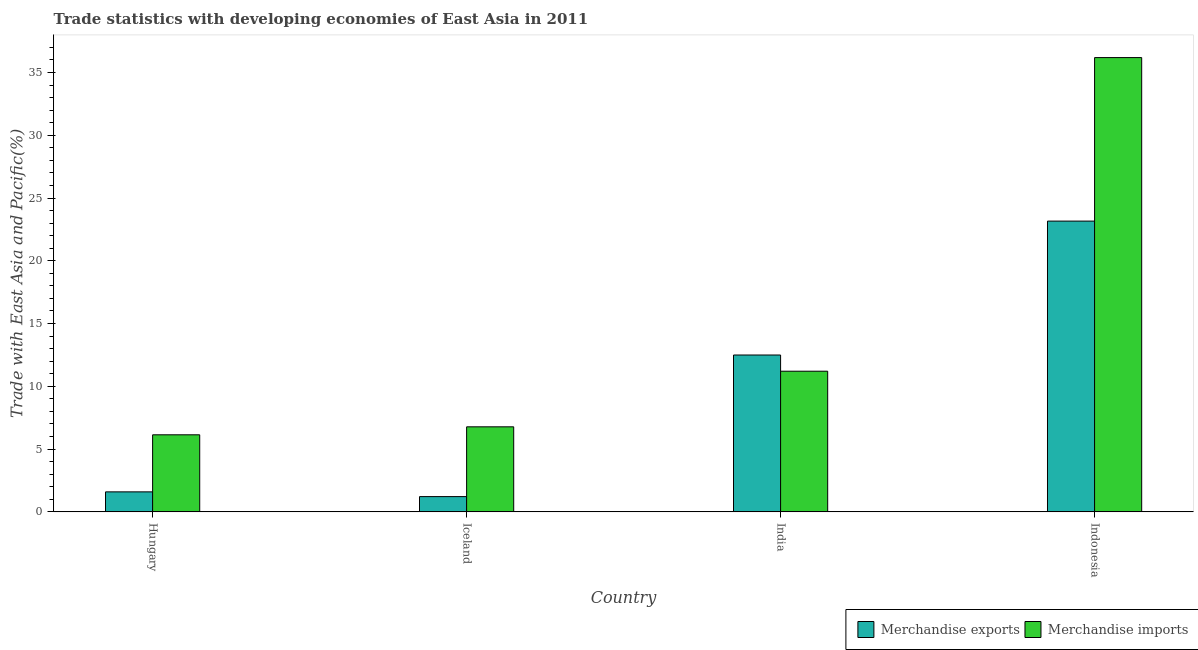How many groups of bars are there?
Make the answer very short. 4. Are the number of bars on each tick of the X-axis equal?
Offer a terse response. Yes. How many bars are there on the 3rd tick from the right?
Give a very brief answer. 2. What is the merchandise exports in Indonesia?
Ensure brevity in your answer.  23.16. Across all countries, what is the maximum merchandise imports?
Make the answer very short. 36.18. Across all countries, what is the minimum merchandise exports?
Give a very brief answer. 1.22. In which country was the merchandise imports minimum?
Ensure brevity in your answer.  Hungary. What is the total merchandise exports in the graph?
Your answer should be compact. 38.46. What is the difference between the merchandise exports in Hungary and that in India?
Make the answer very short. -10.9. What is the difference between the merchandise imports in Indonesia and the merchandise exports in Hungary?
Keep it short and to the point. 34.59. What is the average merchandise exports per country?
Ensure brevity in your answer.  9.62. What is the difference between the merchandise imports and merchandise exports in Indonesia?
Offer a terse response. 13.02. In how many countries, is the merchandise imports greater than 12 %?
Ensure brevity in your answer.  1. What is the ratio of the merchandise imports in Iceland to that in Indonesia?
Keep it short and to the point. 0.19. Is the merchandise imports in Iceland less than that in India?
Your answer should be very brief. Yes. Is the difference between the merchandise exports in Hungary and Iceland greater than the difference between the merchandise imports in Hungary and Iceland?
Provide a succinct answer. Yes. What is the difference between the highest and the second highest merchandise exports?
Make the answer very short. 10.67. What is the difference between the highest and the lowest merchandise exports?
Ensure brevity in your answer.  21.94. In how many countries, is the merchandise imports greater than the average merchandise imports taken over all countries?
Provide a short and direct response. 1. How many bars are there?
Your response must be concise. 8. Does the graph contain grids?
Give a very brief answer. No. What is the title of the graph?
Offer a terse response. Trade statistics with developing economies of East Asia in 2011. What is the label or title of the X-axis?
Offer a terse response. Country. What is the label or title of the Y-axis?
Offer a very short reply. Trade with East Asia and Pacific(%). What is the Trade with East Asia and Pacific(%) in Merchandise exports in Hungary?
Your answer should be compact. 1.59. What is the Trade with East Asia and Pacific(%) in Merchandise imports in Hungary?
Give a very brief answer. 6.14. What is the Trade with East Asia and Pacific(%) of Merchandise exports in Iceland?
Give a very brief answer. 1.22. What is the Trade with East Asia and Pacific(%) in Merchandise imports in Iceland?
Keep it short and to the point. 6.77. What is the Trade with East Asia and Pacific(%) of Merchandise exports in India?
Give a very brief answer. 12.49. What is the Trade with East Asia and Pacific(%) of Merchandise imports in India?
Offer a very short reply. 11.2. What is the Trade with East Asia and Pacific(%) of Merchandise exports in Indonesia?
Your answer should be very brief. 23.16. What is the Trade with East Asia and Pacific(%) of Merchandise imports in Indonesia?
Your answer should be compact. 36.18. Across all countries, what is the maximum Trade with East Asia and Pacific(%) of Merchandise exports?
Ensure brevity in your answer.  23.16. Across all countries, what is the maximum Trade with East Asia and Pacific(%) of Merchandise imports?
Your answer should be compact. 36.18. Across all countries, what is the minimum Trade with East Asia and Pacific(%) in Merchandise exports?
Provide a short and direct response. 1.22. Across all countries, what is the minimum Trade with East Asia and Pacific(%) of Merchandise imports?
Your answer should be very brief. 6.14. What is the total Trade with East Asia and Pacific(%) of Merchandise exports in the graph?
Offer a very short reply. 38.46. What is the total Trade with East Asia and Pacific(%) of Merchandise imports in the graph?
Provide a short and direct response. 60.3. What is the difference between the Trade with East Asia and Pacific(%) in Merchandise exports in Hungary and that in Iceland?
Provide a succinct answer. 0.38. What is the difference between the Trade with East Asia and Pacific(%) of Merchandise imports in Hungary and that in Iceland?
Provide a succinct answer. -0.64. What is the difference between the Trade with East Asia and Pacific(%) in Merchandise imports in Hungary and that in India?
Your answer should be very brief. -5.07. What is the difference between the Trade with East Asia and Pacific(%) of Merchandise exports in Hungary and that in Indonesia?
Your response must be concise. -21.57. What is the difference between the Trade with East Asia and Pacific(%) of Merchandise imports in Hungary and that in Indonesia?
Provide a short and direct response. -30.04. What is the difference between the Trade with East Asia and Pacific(%) of Merchandise exports in Iceland and that in India?
Offer a terse response. -11.28. What is the difference between the Trade with East Asia and Pacific(%) of Merchandise imports in Iceland and that in India?
Ensure brevity in your answer.  -4.43. What is the difference between the Trade with East Asia and Pacific(%) in Merchandise exports in Iceland and that in Indonesia?
Keep it short and to the point. -21.94. What is the difference between the Trade with East Asia and Pacific(%) of Merchandise imports in Iceland and that in Indonesia?
Offer a very short reply. -29.41. What is the difference between the Trade with East Asia and Pacific(%) in Merchandise exports in India and that in Indonesia?
Ensure brevity in your answer.  -10.67. What is the difference between the Trade with East Asia and Pacific(%) of Merchandise imports in India and that in Indonesia?
Your answer should be compact. -24.98. What is the difference between the Trade with East Asia and Pacific(%) of Merchandise exports in Hungary and the Trade with East Asia and Pacific(%) of Merchandise imports in Iceland?
Ensure brevity in your answer.  -5.18. What is the difference between the Trade with East Asia and Pacific(%) in Merchandise exports in Hungary and the Trade with East Asia and Pacific(%) in Merchandise imports in India?
Make the answer very short. -9.61. What is the difference between the Trade with East Asia and Pacific(%) in Merchandise exports in Hungary and the Trade with East Asia and Pacific(%) in Merchandise imports in Indonesia?
Keep it short and to the point. -34.59. What is the difference between the Trade with East Asia and Pacific(%) in Merchandise exports in Iceland and the Trade with East Asia and Pacific(%) in Merchandise imports in India?
Make the answer very short. -9.99. What is the difference between the Trade with East Asia and Pacific(%) of Merchandise exports in Iceland and the Trade with East Asia and Pacific(%) of Merchandise imports in Indonesia?
Your response must be concise. -34.97. What is the difference between the Trade with East Asia and Pacific(%) of Merchandise exports in India and the Trade with East Asia and Pacific(%) of Merchandise imports in Indonesia?
Provide a succinct answer. -23.69. What is the average Trade with East Asia and Pacific(%) of Merchandise exports per country?
Your answer should be very brief. 9.62. What is the average Trade with East Asia and Pacific(%) of Merchandise imports per country?
Offer a terse response. 15.08. What is the difference between the Trade with East Asia and Pacific(%) of Merchandise exports and Trade with East Asia and Pacific(%) of Merchandise imports in Hungary?
Offer a terse response. -4.54. What is the difference between the Trade with East Asia and Pacific(%) in Merchandise exports and Trade with East Asia and Pacific(%) in Merchandise imports in Iceland?
Keep it short and to the point. -5.56. What is the difference between the Trade with East Asia and Pacific(%) of Merchandise exports and Trade with East Asia and Pacific(%) of Merchandise imports in India?
Provide a short and direct response. 1.29. What is the difference between the Trade with East Asia and Pacific(%) of Merchandise exports and Trade with East Asia and Pacific(%) of Merchandise imports in Indonesia?
Provide a succinct answer. -13.02. What is the ratio of the Trade with East Asia and Pacific(%) in Merchandise exports in Hungary to that in Iceland?
Offer a terse response. 1.31. What is the ratio of the Trade with East Asia and Pacific(%) of Merchandise imports in Hungary to that in Iceland?
Keep it short and to the point. 0.91. What is the ratio of the Trade with East Asia and Pacific(%) of Merchandise exports in Hungary to that in India?
Your response must be concise. 0.13. What is the ratio of the Trade with East Asia and Pacific(%) in Merchandise imports in Hungary to that in India?
Offer a very short reply. 0.55. What is the ratio of the Trade with East Asia and Pacific(%) in Merchandise exports in Hungary to that in Indonesia?
Keep it short and to the point. 0.07. What is the ratio of the Trade with East Asia and Pacific(%) of Merchandise imports in Hungary to that in Indonesia?
Give a very brief answer. 0.17. What is the ratio of the Trade with East Asia and Pacific(%) in Merchandise exports in Iceland to that in India?
Your answer should be very brief. 0.1. What is the ratio of the Trade with East Asia and Pacific(%) in Merchandise imports in Iceland to that in India?
Offer a terse response. 0.6. What is the ratio of the Trade with East Asia and Pacific(%) in Merchandise exports in Iceland to that in Indonesia?
Give a very brief answer. 0.05. What is the ratio of the Trade with East Asia and Pacific(%) of Merchandise imports in Iceland to that in Indonesia?
Offer a very short reply. 0.19. What is the ratio of the Trade with East Asia and Pacific(%) of Merchandise exports in India to that in Indonesia?
Provide a succinct answer. 0.54. What is the ratio of the Trade with East Asia and Pacific(%) of Merchandise imports in India to that in Indonesia?
Give a very brief answer. 0.31. What is the difference between the highest and the second highest Trade with East Asia and Pacific(%) in Merchandise exports?
Offer a very short reply. 10.67. What is the difference between the highest and the second highest Trade with East Asia and Pacific(%) in Merchandise imports?
Ensure brevity in your answer.  24.98. What is the difference between the highest and the lowest Trade with East Asia and Pacific(%) of Merchandise exports?
Provide a succinct answer. 21.94. What is the difference between the highest and the lowest Trade with East Asia and Pacific(%) of Merchandise imports?
Your answer should be compact. 30.04. 